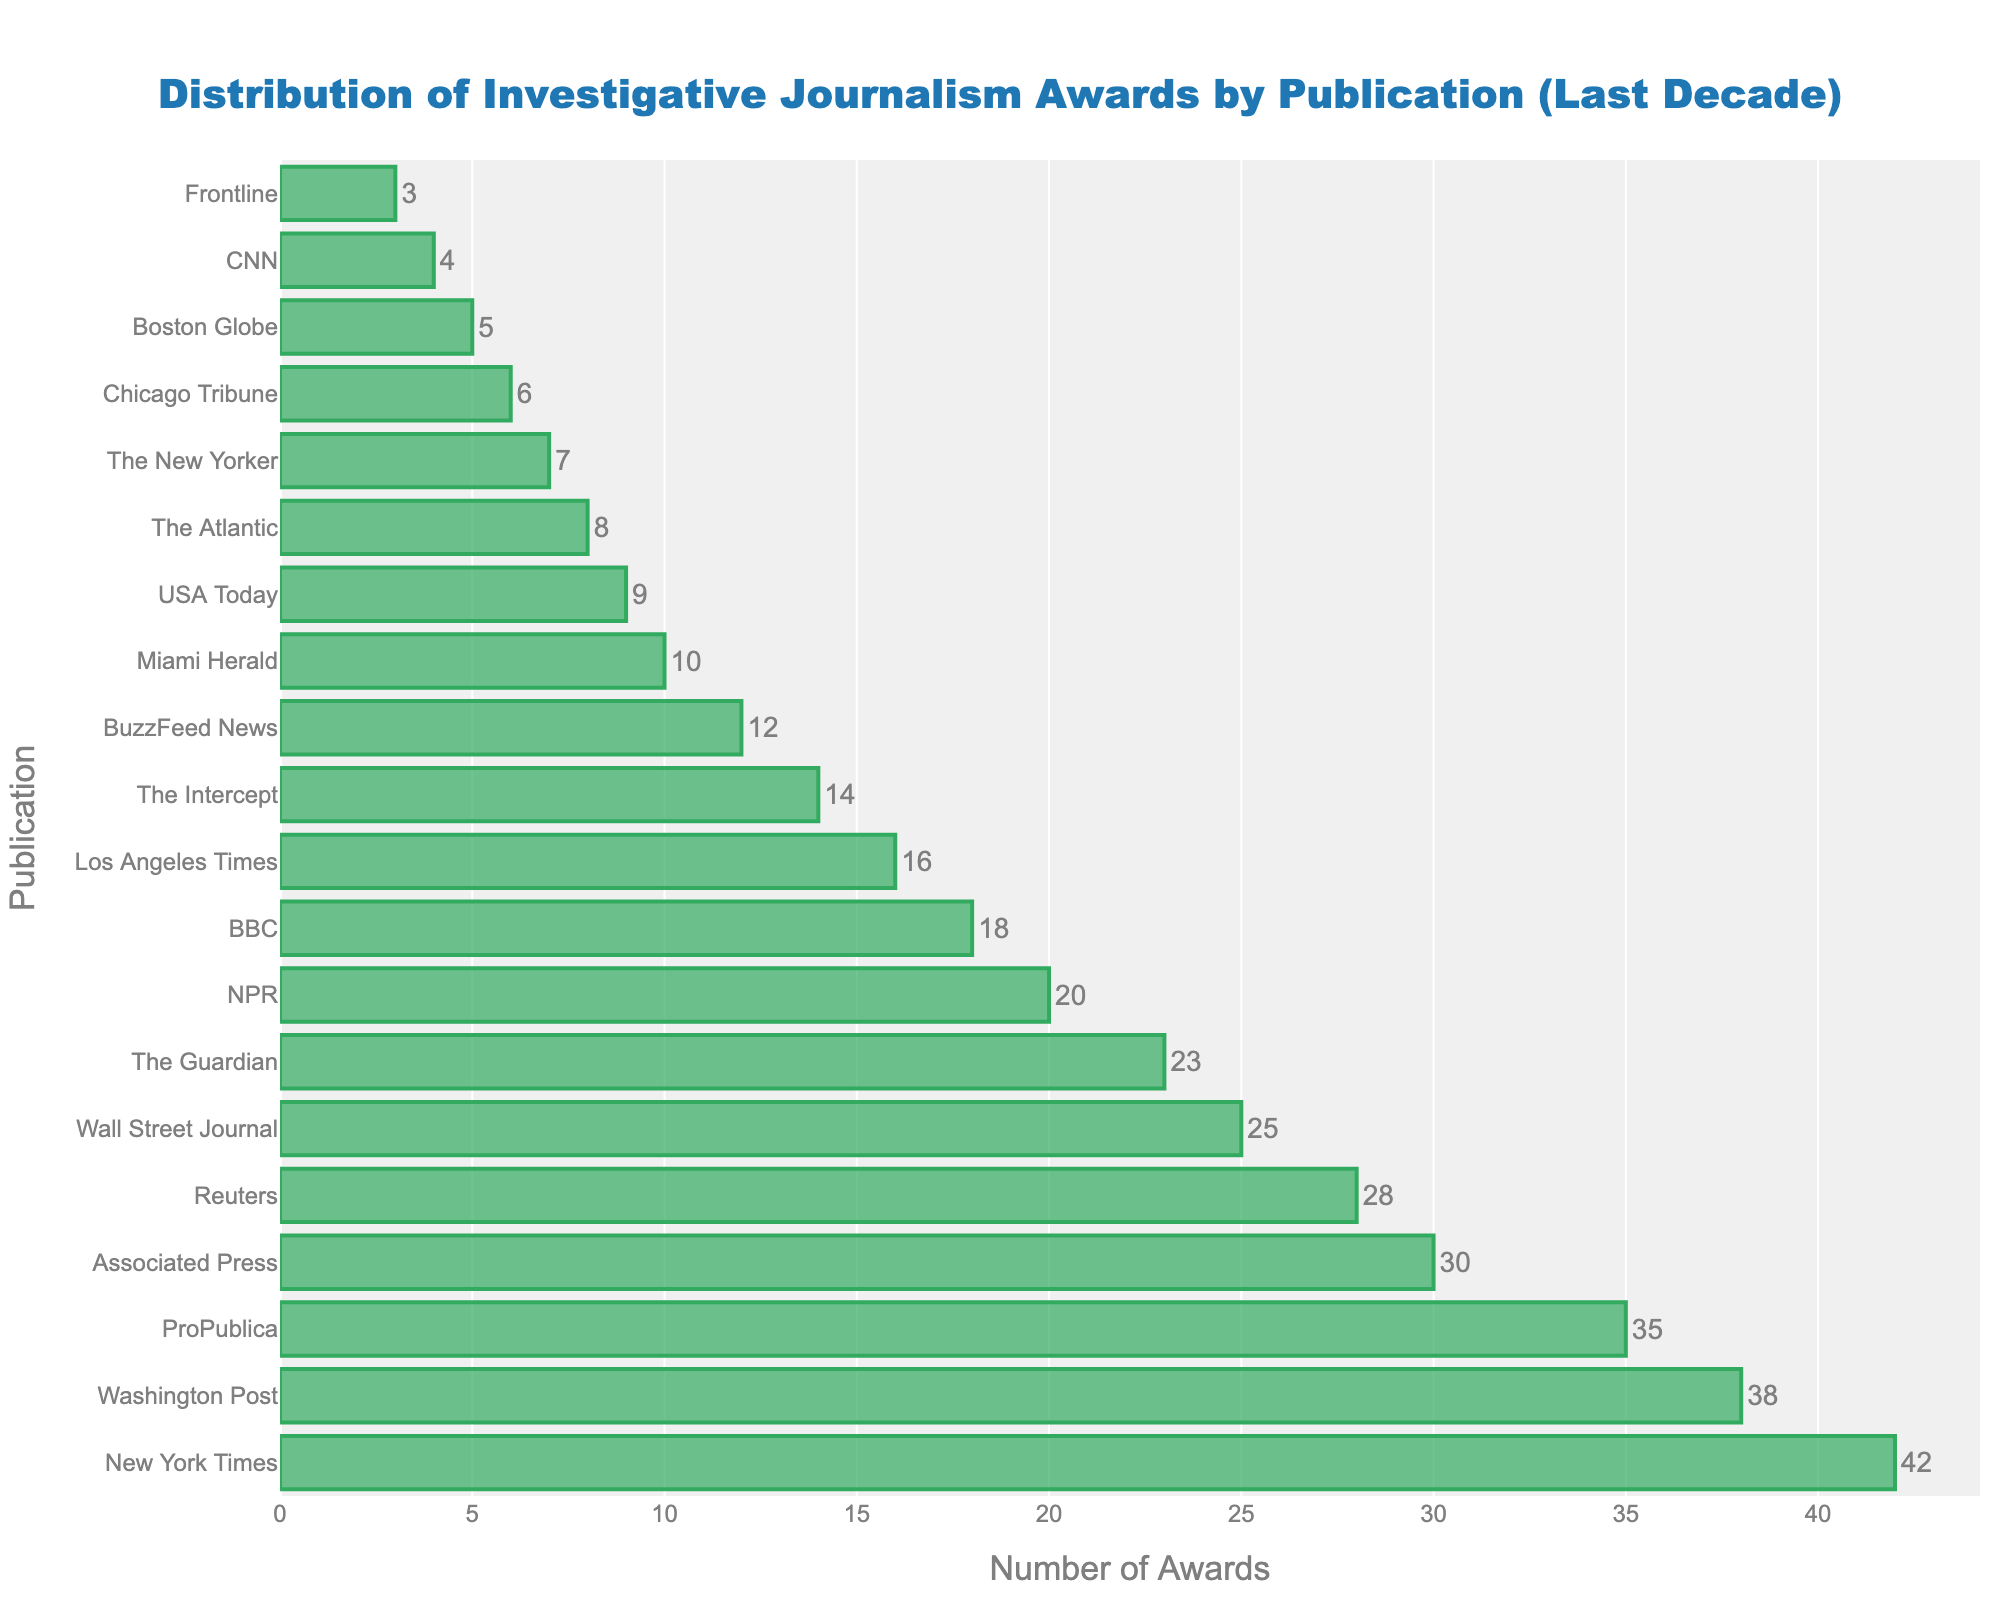Which publication has the highest number of awards? By looking at the bar chart, identify the bar that extends the furthest to the right. This bar represents the publication with the highest number of awards.
Answer: New York Times How many awards did ProPublica win? Locate the ProPublica bar on the chart and read the label or value associated with it.
Answer: 35 Which publication has fewer awards: NPR or Los Angeles Times? Compare the lengths of the bars for NPR and Los Angeles Times. The bar that is shorter represents the publication with fewer awards.
Answer: Los Angeles Times What is the total number of awards won by the top three publications? The top three publications are New York Times (42), Washington Post (38), and ProPublica (35). Sum these values: 42 + 38 + 35 = 115
Answer: 115 What is the difference in the number of awards between Reuters and Wall Street Journal? Identify the number of awards for Reuters (28) and Wall Street Journal (25) and subtract the latter from the former: 28 - 25 = 3
Answer: 3 Which is more common: publications with fewer than 10 awards or those with more than 30 awards? Count the number of publications with fewer than 10 awards (Miami Herald, USA Today, The Atlantic, The New Yorker, Chicago Tribune, Boston Globe, CNN, Frontline) and those with more than 30 awards (New York Times, Washington Post, ProPublica, Associated Press, Reuters). Compare the counts (8 vs. 5).
Answer: Publications with fewer than 10 awards Which publication has won exactly 12 awards? Find the bar that corresponds to 12 awards and identify the associated publication.
Answer: BuzzFeed News What is the average number of awards for publications with 10 or more awards? Sum the awards for these publications (42+38+35+30+28+25+23+20+18+16+14+12+10) and divide by the number of these publications (13): (311 / 13) ≈ 23.92
Answer: 23.92 How many more awards did BBC win compared to CNN? Identify the number of awards for BBC (18) and CNN (4) and subtract the latter from the former: 18 - 4 = 14
Answer: 14 Which publication ranks 5th in terms of the number of awards? List the publications in descending order of awards and identify the 5th one.
Answer: Reuters 